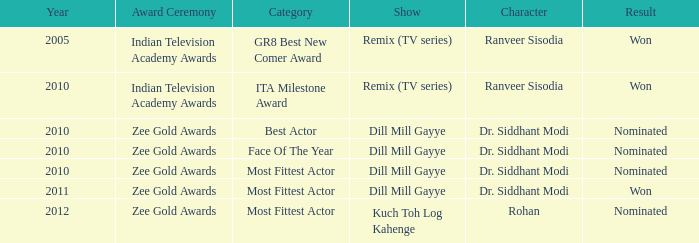Which show has a character of Rohan? Kuch Toh Log Kahenge. 